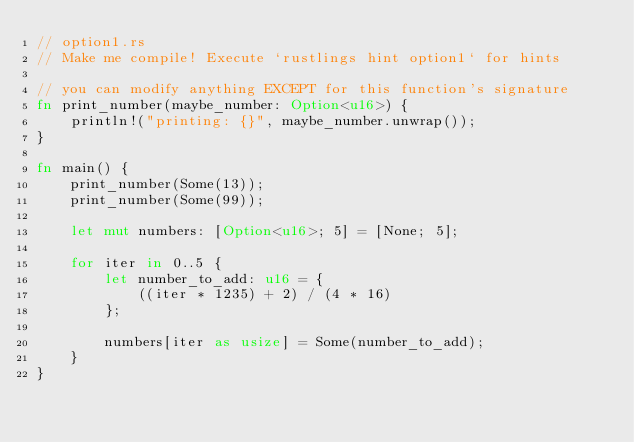Convert code to text. <code><loc_0><loc_0><loc_500><loc_500><_Rust_>// option1.rs
// Make me compile! Execute `rustlings hint option1` for hints

// you can modify anything EXCEPT for this function's signature
fn print_number(maybe_number: Option<u16>) {
    println!("printing: {}", maybe_number.unwrap());
}

fn main() {
    print_number(Some(13));
    print_number(Some(99));

    let mut numbers: [Option<u16>; 5] = [None; 5];

    for iter in 0..5 {
        let number_to_add: u16 = {
            ((iter * 1235) + 2) / (4 * 16)
        };

        numbers[iter as usize] = Some(number_to_add);
    }
}
</code> 